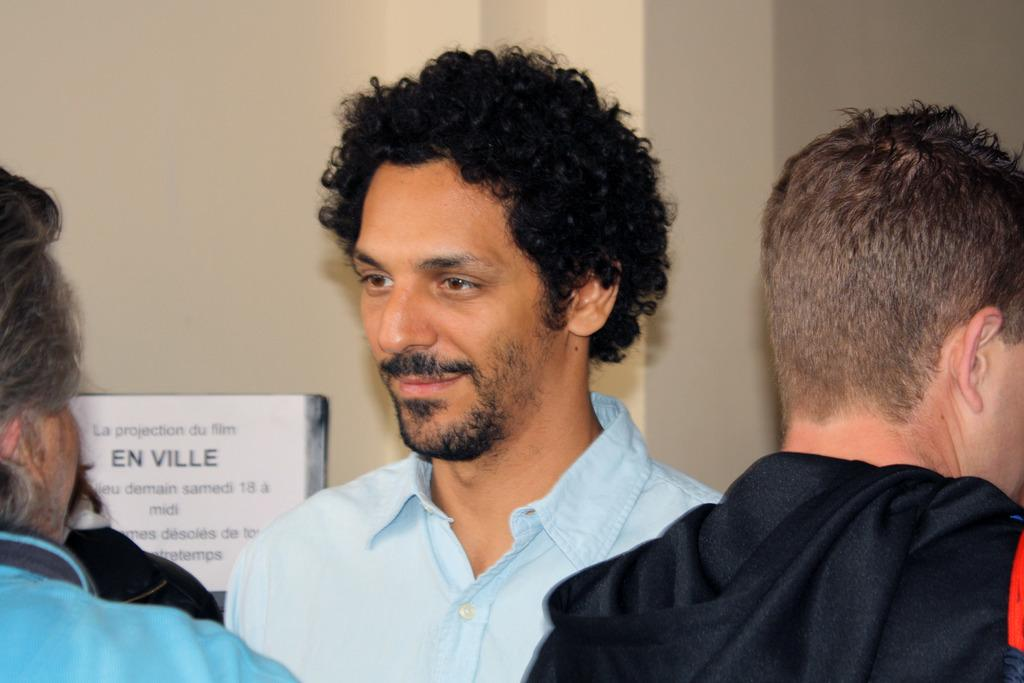Who or what is present in the image? There are people in the image. What object can be seen in the image? There is a board in the image. What can be seen in the background of the image? There is a wall in the background of the image. What type of animal is participating in the discussion on the board? There is no animal present in the image, and the board does not depict a discussion. 